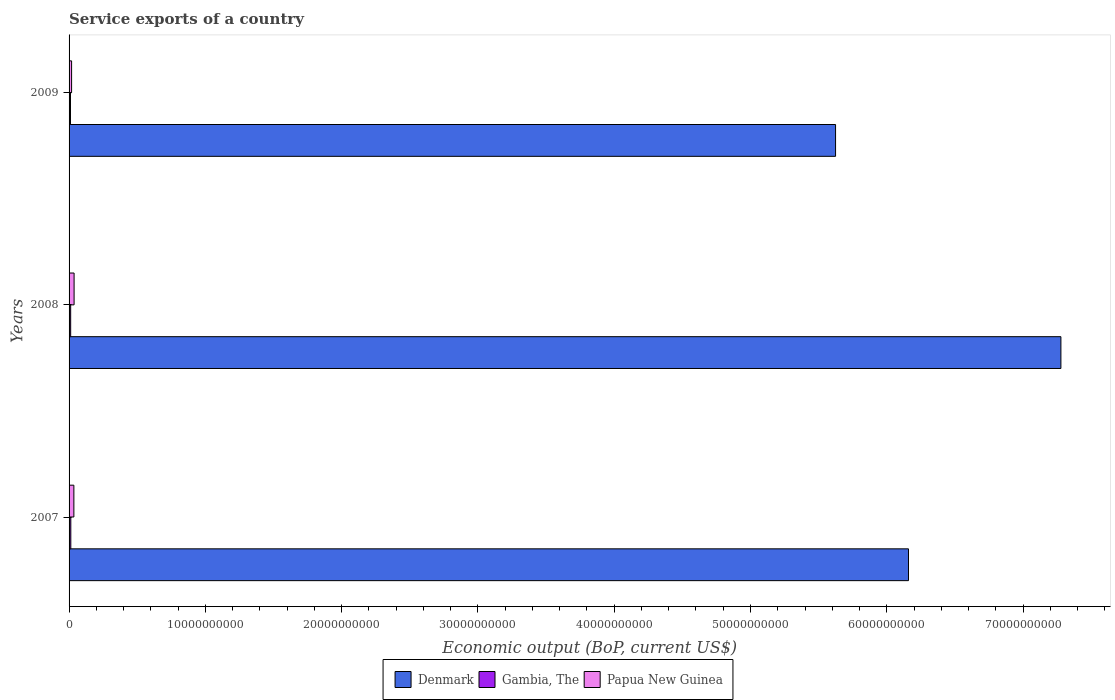How many different coloured bars are there?
Your answer should be very brief. 3. How many groups of bars are there?
Offer a very short reply. 3. Are the number of bars on each tick of the Y-axis equal?
Make the answer very short. Yes. How many bars are there on the 2nd tick from the top?
Offer a terse response. 3. What is the label of the 3rd group of bars from the top?
Make the answer very short. 2007. In how many cases, is the number of bars for a given year not equal to the number of legend labels?
Offer a terse response. 0. What is the service exports in Gambia, The in 2009?
Your response must be concise. 1.04e+08. Across all years, what is the maximum service exports in Papua New Guinea?
Provide a succinct answer. 3.69e+08. Across all years, what is the minimum service exports in Gambia, The?
Offer a terse response. 1.04e+08. In which year was the service exports in Papua New Guinea minimum?
Your answer should be very brief. 2009. What is the total service exports in Papua New Guinea in the graph?
Offer a very short reply. 9.07e+08. What is the difference between the service exports in Papua New Guinea in 2007 and that in 2008?
Your answer should be very brief. -1.61e+07. What is the difference between the service exports in Papua New Guinea in 2009 and the service exports in Gambia, The in 2007?
Ensure brevity in your answer.  5.75e+07. What is the average service exports in Denmark per year?
Your answer should be very brief. 6.35e+1. In the year 2007, what is the difference between the service exports in Gambia, The and service exports in Papua New Guinea?
Offer a very short reply. -2.25e+08. What is the ratio of the service exports in Papua New Guinea in 2007 to that in 2008?
Make the answer very short. 0.96. What is the difference between the highest and the second highest service exports in Papua New Guinea?
Provide a succinct answer. 1.61e+07. What is the difference between the highest and the lowest service exports in Papua New Guinea?
Make the answer very short. 1.83e+08. In how many years, is the service exports in Gambia, The greater than the average service exports in Gambia, The taken over all years?
Provide a succinct answer. 2. Is the sum of the service exports in Papua New Guinea in 2008 and 2009 greater than the maximum service exports in Gambia, The across all years?
Keep it short and to the point. Yes. What does the 1st bar from the top in 2009 represents?
Give a very brief answer. Papua New Guinea. What does the 2nd bar from the bottom in 2009 represents?
Provide a succinct answer. Gambia, The. How many bars are there?
Your answer should be very brief. 9. Are all the bars in the graph horizontal?
Provide a succinct answer. Yes. How many years are there in the graph?
Your answer should be very brief. 3. Are the values on the major ticks of X-axis written in scientific E-notation?
Keep it short and to the point. No. Where does the legend appear in the graph?
Your answer should be very brief. Bottom center. How many legend labels are there?
Give a very brief answer. 3. How are the legend labels stacked?
Your answer should be compact. Horizontal. What is the title of the graph?
Your answer should be compact. Service exports of a country. What is the label or title of the X-axis?
Provide a succinct answer. Economic output (BoP, current US$). What is the Economic output (BoP, current US$) in Denmark in 2007?
Ensure brevity in your answer.  6.16e+1. What is the Economic output (BoP, current US$) in Gambia, The in 2007?
Give a very brief answer. 1.28e+08. What is the Economic output (BoP, current US$) in Papua New Guinea in 2007?
Your response must be concise. 3.53e+08. What is the Economic output (BoP, current US$) of Denmark in 2008?
Give a very brief answer. 7.28e+1. What is the Economic output (BoP, current US$) in Gambia, The in 2008?
Ensure brevity in your answer.  1.18e+08. What is the Economic output (BoP, current US$) of Papua New Guinea in 2008?
Make the answer very short. 3.69e+08. What is the Economic output (BoP, current US$) of Denmark in 2009?
Give a very brief answer. 5.62e+1. What is the Economic output (BoP, current US$) of Gambia, The in 2009?
Keep it short and to the point. 1.04e+08. What is the Economic output (BoP, current US$) in Papua New Guinea in 2009?
Offer a very short reply. 1.85e+08. Across all years, what is the maximum Economic output (BoP, current US$) of Denmark?
Your answer should be compact. 7.28e+1. Across all years, what is the maximum Economic output (BoP, current US$) in Gambia, The?
Your response must be concise. 1.28e+08. Across all years, what is the maximum Economic output (BoP, current US$) in Papua New Guinea?
Provide a succinct answer. 3.69e+08. Across all years, what is the minimum Economic output (BoP, current US$) in Denmark?
Offer a very short reply. 5.62e+1. Across all years, what is the minimum Economic output (BoP, current US$) of Gambia, The?
Your response must be concise. 1.04e+08. Across all years, what is the minimum Economic output (BoP, current US$) of Papua New Guinea?
Offer a terse response. 1.85e+08. What is the total Economic output (BoP, current US$) of Denmark in the graph?
Offer a very short reply. 1.91e+11. What is the total Economic output (BoP, current US$) in Gambia, The in the graph?
Offer a terse response. 3.50e+08. What is the total Economic output (BoP, current US$) of Papua New Guinea in the graph?
Your response must be concise. 9.07e+08. What is the difference between the Economic output (BoP, current US$) in Denmark in 2007 and that in 2008?
Your response must be concise. -1.12e+1. What is the difference between the Economic output (BoP, current US$) in Gambia, The in 2007 and that in 2008?
Keep it short and to the point. 1.04e+07. What is the difference between the Economic output (BoP, current US$) in Papua New Guinea in 2007 and that in 2008?
Make the answer very short. -1.61e+07. What is the difference between the Economic output (BoP, current US$) in Denmark in 2007 and that in 2009?
Offer a terse response. 5.35e+09. What is the difference between the Economic output (BoP, current US$) of Gambia, The in 2007 and that in 2009?
Ensure brevity in your answer.  2.38e+07. What is the difference between the Economic output (BoP, current US$) in Papua New Guinea in 2007 and that in 2009?
Offer a terse response. 1.67e+08. What is the difference between the Economic output (BoP, current US$) in Denmark in 2008 and that in 2009?
Make the answer very short. 1.65e+1. What is the difference between the Economic output (BoP, current US$) of Gambia, The in 2008 and that in 2009?
Keep it short and to the point. 1.34e+07. What is the difference between the Economic output (BoP, current US$) of Papua New Guinea in 2008 and that in 2009?
Offer a very short reply. 1.83e+08. What is the difference between the Economic output (BoP, current US$) in Denmark in 2007 and the Economic output (BoP, current US$) in Gambia, The in 2008?
Provide a succinct answer. 6.15e+1. What is the difference between the Economic output (BoP, current US$) in Denmark in 2007 and the Economic output (BoP, current US$) in Papua New Guinea in 2008?
Provide a succinct answer. 6.12e+1. What is the difference between the Economic output (BoP, current US$) in Gambia, The in 2007 and the Economic output (BoP, current US$) in Papua New Guinea in 2008?
Give a very brief answer. -2.41e+08. What is the difference between the Economic output (BoP, current US$) in Denmark in 2007 and the Economic output (BoP, current US$) in Gambia, The in 2009?
Your answer should be very brief. 6.15e+1. What is the difference between the Economic output (BoP, current US$) in Denmark in 2007 and the Economic output (BoP, current US$) in Papua New Guinea in 2009?
Offer a terse response. 6.14e+1. What is the difference between the Economic output (BoP, current US$) of Gambia, The in 2007 and the Economic output (BoP, current US$) of Papua New Guinea in 2009?
Give a very brief answer. -5.75e+07. What is the difference between the Economic output (BoP, current US$) of Denmark in 2008 and the Economic output (BoP, current US$) of Gambia, The in 2009?
Offer a very short reply. 7.27e+1. What is the difference between the Economic output (BoP, current US$) of Denmark in 2008 and the Economic output (BoP, current US$) of Papua New Guinea in 2009?
Provide a short and direct response. 7.26e+1. What is the difference between the Economic output (BoP, current US$) of Gambia, The in 2008 and the Economic output (BoP, current US$) of Papua New Guinea in 2009?
Provide a short and direct response. -6.78e+07. What is the average Economic output (BoP, current US$) of Denmark per year?
Provide a succinct answer. 6.35e+1. What is the average Economic output (BoP, current US$) in Gambia, The per year?
Offer a very short reply. 1.17e+08. What is the average Economic output (BoP, current US$) in Papua New Guinea per year?
Offer a terse response. 3.02e+08. In the year 2007, what is the difference between the Economic output (BoP, current US$) in Denmark and Economic output (BoP, current US$) in Gambia, The?
Keep it short and to the point. 6.15e+1. In the year 2007, what is the difference between the Economic output (BoP, current US$) of Denmark and Economic output (BoP, current US$) of Papua New Guinea?
Ensure brevity in your answer.  6.12e+1. In the year 2007, what is the difference between the Economic output (BoP, current US$) in Gambia, The and Economic output (BoP, current US$) in Papua New Guinea?
Provide a short and direct response. -2.25e+08. In the year 2008, what is the difference between the Economic output (BoP, current US$) of Denmark and Economic output (BoP, current US$) of Gambia, The?
Provide a short and direct response. 7.27e+1. In the year 2008, what is the difference between the Economic output (BoP, current US$) of Denmark and Economic output (BoP, current US$) of Papua New Guinea?
Provide a short and direct response. 7.24e+1. In the year 2008, what is the difference between the Economic output (BoP, current US$) of Gambia, The and Economic output (BoP, current US$) of Papua New Guinea?
Your answer should be very brief. -2.51e+08. In the year 2009, what is the difference between the Economic output (BoP, current US$) in Denmark and Economic output (BoP, current US$) in Gambia, The?
Your answer should be very brief. 5.61e+1. In the year 2009, what is the difference between the Economic output (BoP, current US$) in Denmark and Economic output (BoP, current US$) in Papua New Guinea?
Your answer should be compact. 5.61e+1. In the year 2009, what is the difference between the Economic output (BoP, current US$) in Gambia, The and Economic output (BoP, current US$) in Papua New Guinea?
Give a very brief answer. -8.12e+07. What is the ratio of the Economic output (BoP, current US$) in Denmark in 2007 to that in 2008?
Keep it short and to the point. 0.85. What is the ratio of the Economic output (BoP, current US$) in Gambia, The in 2007 to that in 2008?
Give a very brief answer. 1.09. What is the ratio of the Economic output (BoP, current US$) of Papua New Guinea in 2007 to that in 2008?
Offer a terse response. 0.96. What is the ratio of the Economic output (BoP, current US$) in Denmark in 2007 to that in 2009?
Your answer should be compact. 1.1. What is the ratio of the Economic output (BoP, current US$) of Gambia, The in 2007 to that in 2009?
Keep it short and to the point. 1.23. What is the ratio of the Economic output (BoP, current US$) in Papua New Guinea in 2007 to that in 2009?
Give a very brief answer. 1.9. What is the ratio of the Economic output (BoP, current US$) in Denmark in 2008 to that in 2009?
Offer a terse response. 1.29. What is the ratio of the Economic output (BoP, current US$) of Gambia, The in 2008 to that in 2009?
Give a very brief answer. 1.13. What is the ratio of the Economic output (BoP, current US$) of Papua New Guinea in 2008 to that in 2009?
Offer a terse response. 1.99. What is the difference between the highest and the second highest Economic output (BoP, current US$) in Denmark?
Ensure brevity in your answer.  1.12e+1. What is the difference between the highest and the second highest Economic output (BoP, current US$) of Gambia, The?
Provide a succinct answer. 1.04e+07. What is the difference between the highest and the second highest Economic output (BoP, current US$) of Papua New Guinea?
Offer a terse response. 1.61e+07. What is the difference between the highest and the lowest Economic output (BoP, current US$) of Denmark?
Provide a short and direct response. 1.65e+1. What is the difference between the highest and the lowest Economic output (BoP, current US$) of Gambia, The?
Provide a succinct answer. 2.38e+07. What is the difference between the highest and the lowest Economic output (BoP, current US$) in Papua New Guinea?
Ensure brevity in your answer.  1.83e+08. 